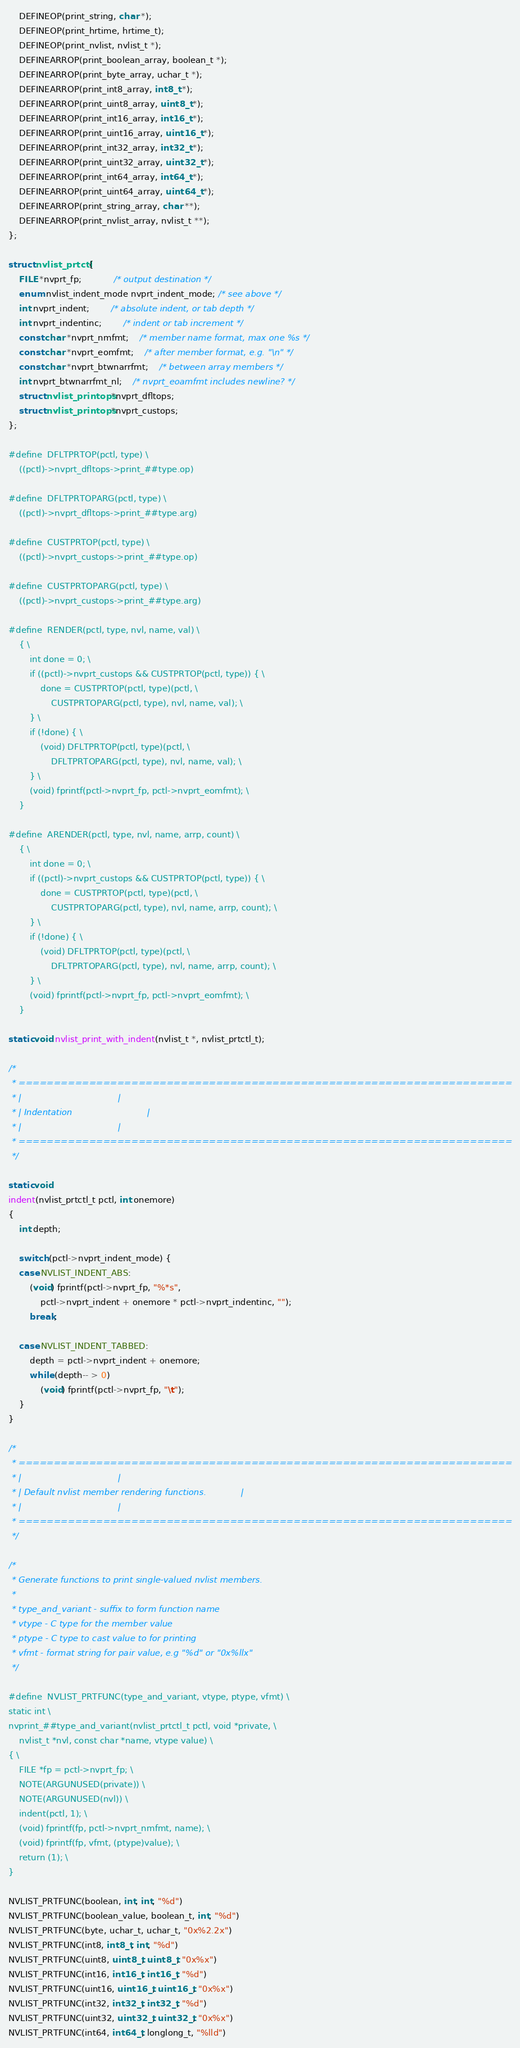Convert code to text. <code><loc_0><loc_0><loc_500><loc_500><_C_>	DEFINEOP(print_string, char *);
	DEFINEOP(print_hrtime, hrtime_t);
	DEFINEOP(print_nvlist, nvlist_t *);
	DEFINEARROP(print_boolean_array, boolean_t *);
	DEFINEARROP(print_byte_array, uchar_t *);
	DEFINEARROP(print_int8_array, int8_t *);
	DEFINEARROP(print_uint8_array, uint8_t *);
	DEFINEARROP(print_int16_array, int16_t *);
	DEFINEARROP(print_uint16_array, uint16_t *);
	DEFINEARROP(print_int32_array, int32_t *);
	DEFINEARROP(print_uint32_array, uint32_t *);
	DEFINEARROP(print_int64_array, int64_t *);
	DEFINEARROP(print_uint64_array, uint64_t *);
	DEFINEARROP(print_string_array, char **);
	DEFINEARROP(print_nvlist_array, nvlist_t **);
};

struct nvlist_prtctl {
	FILE *nvprt_fp;			/* output destination */
	enum nvlist_indent_mode nvprt_indent_mode; /* see above */
	int nvprt_indent;		/* absolute indent, or tab depth */
	int nvprt_indentinc;		/* indent or tab increment */
	const char *nvprt_nmfmt;	/* member name format, max one %s */
	const char *nvprt_eomfmt;	/* after member format, e.g. "\n" */
	const char *nvprt_btwnarrfmt;	/* between array members */
	int nvprt_btwnarrfmt_nl;	/* nvprt_eoamfmt includes newline? */
	struct nvlist_printops *nvprt_dfltops;
	struct nvlist_printops *nvprt_custops;
};

#define	DFLTPRTOP(pctl, type) \
	((pctl)->nvprt_dfltops->print_##type.op)

#define	DFLTPRTOPARG(pctl, type) \
	((pctl)->nvprt_dfltops->print_##type.arg)

#define	CUSTPRTOP(pctl, type) \
	((pctl)->nvprt_custops->print_##type.op)

#define	CUSTPRTOPARG(pctl, type) \
	((pctl)->nvprt_custops->print_##type.arg)

#define	RENDER(pctl, type, nvl, name, val) \
	{ \
		int done = 0; \
		if ((pctl)->nvprt_custops && CUSTPRTOP(pctl, type)) { \
			done = CUSTPRTOP(pctl, type)(pctl, \
			    CUSTPRTOPARG(pctl, type), nvl, name, val); \
		} \
		if (!done) { \
			(void) DFLTPRTOP(pctl, type)(pctl, \
			    DFLTPRTOPARG(pctl, type), nvl, name, val); \
		} \
		(void) fprintf(pctl->nvprt_fp, pctl->nvprt_eomfmt); \
	}

#define	ARENDER(pctl, type, nvl, name, arrp, count) \
	{ \
		int done = 0; \
		if ((pctl)->nvprt_custops && CUSTPRTOP(pctl, type)) { \
			done = CUSTPRTOP(pctl, type)(pctl, \
			    CUSTPRTOPARG(pctl, type), nvl, name, arrp, count); \
		} \
		if (!done) { \
			(void) DFLTPRTOP(pctl, type)(pctl, \
			    DFLTPRTOPARG(pctl, type), nvl, name, arrp, count); \
		} \
		(void) fprintf(pctl->nvprt_fp, pctl->nvprt_eomfmt); \
	}

static void nvlist_print_with_indent(nvlist_t *, nvlist_prtctl_t);

/*
 * ======================================================================
 * |									|
 * | Indentation							|
 * |									|
 * ======================================================================
 */

static void
indent(nvlist_prtctl_t pctl, int onemore)
{
	int depth;

	switch (pctl->nvprt_indent_mode) {
	case NVLIST_INDENT_ABS:
		(void) fprintf(pctl->nvprt_fp, "%*s",
		    pctl->nvprt_indent + onemore * pctl->nvprt_indentinc, "");
		break;

	case NVLIST_INDENT_TABBED:
		depth = pctl->nvprt_indent + onemore;
		while (depth-- > 0)
			(void) fprintf(pctl->nvprt_fp, "\t");
	}
}

/*
 * ======================================================================
 * |									|
 * | Default nvlist member rendering functions.				|
 * |									|
 * ======================================================================
 */

/*
 * Generate functions to print single-valued nvlist members.
 *
 * type_and_variant - suffix to form function name
 * vtype - C type for the member value
 * ptype - C type to cast value to for printing
 * vfmt - format string for pair value, e.g "%d" or "0x%llx"
 */

#define	NVLIST_PRTFUNC(type_and_variant, vtype, ptype, vfmt) \
static int \
nvprint_##type_and_variant(nvlist_prtctl_t pctl, void *private, \
    nvlist_t *nvl, const char *name, vtype value) \
{ \
	FILE *fp = pctl->nvprt_fp; \
	NOTE(ARGUNUSED(private)) \
	NOTE(ARGUNUSED(nvl)) \
	indent(pctl, 1); \
	(void) fprintf(fp, pctl->nvprt_nmfmt, name); \
	(void) fprintf(fp, vfmt, (ptype)value); \
	return (1); \
}

NVLIST_PRTFUNC(boolean, int, int, "%d")
NVLIST_PRTFUNC(boolean_value, boolean_t, int, "%d")
NVLIST_PRTFUNC(byte, uchar_t, uchar_t, "0x%2.2x")
NVLIST_PRTFUNC(int8, int8_t, int, "%d")
NVLIST_PRTFUNC(uint8, uint8_t, uint8_t, "0x%x")
NVLIST_PRTFUNC(int16, int16_t, int16_t, "%d")
NVLIST_PRTFUNC(uint16, uint16_t, uint16_t, "0x%x")
NVLIST_PRTFUNC(int32, int32_t, int32_t, "%d")
NVLIST_PRTFUNC(uint32, uint32_t, uint32_t, "0x%x")
NVLIST_PRTFUNC(int64, int64_t, longlong_t, "%lld")</code> 